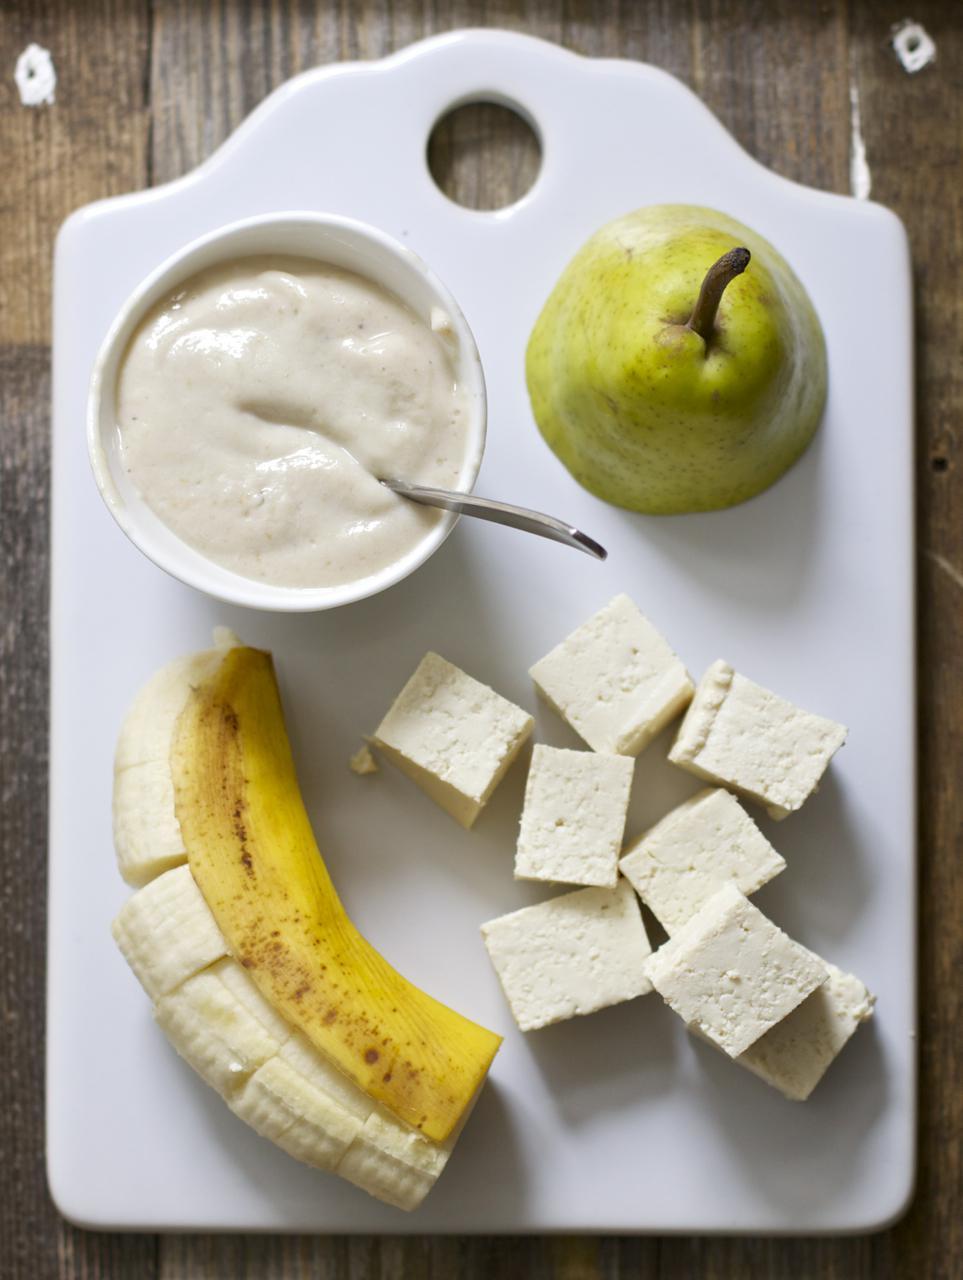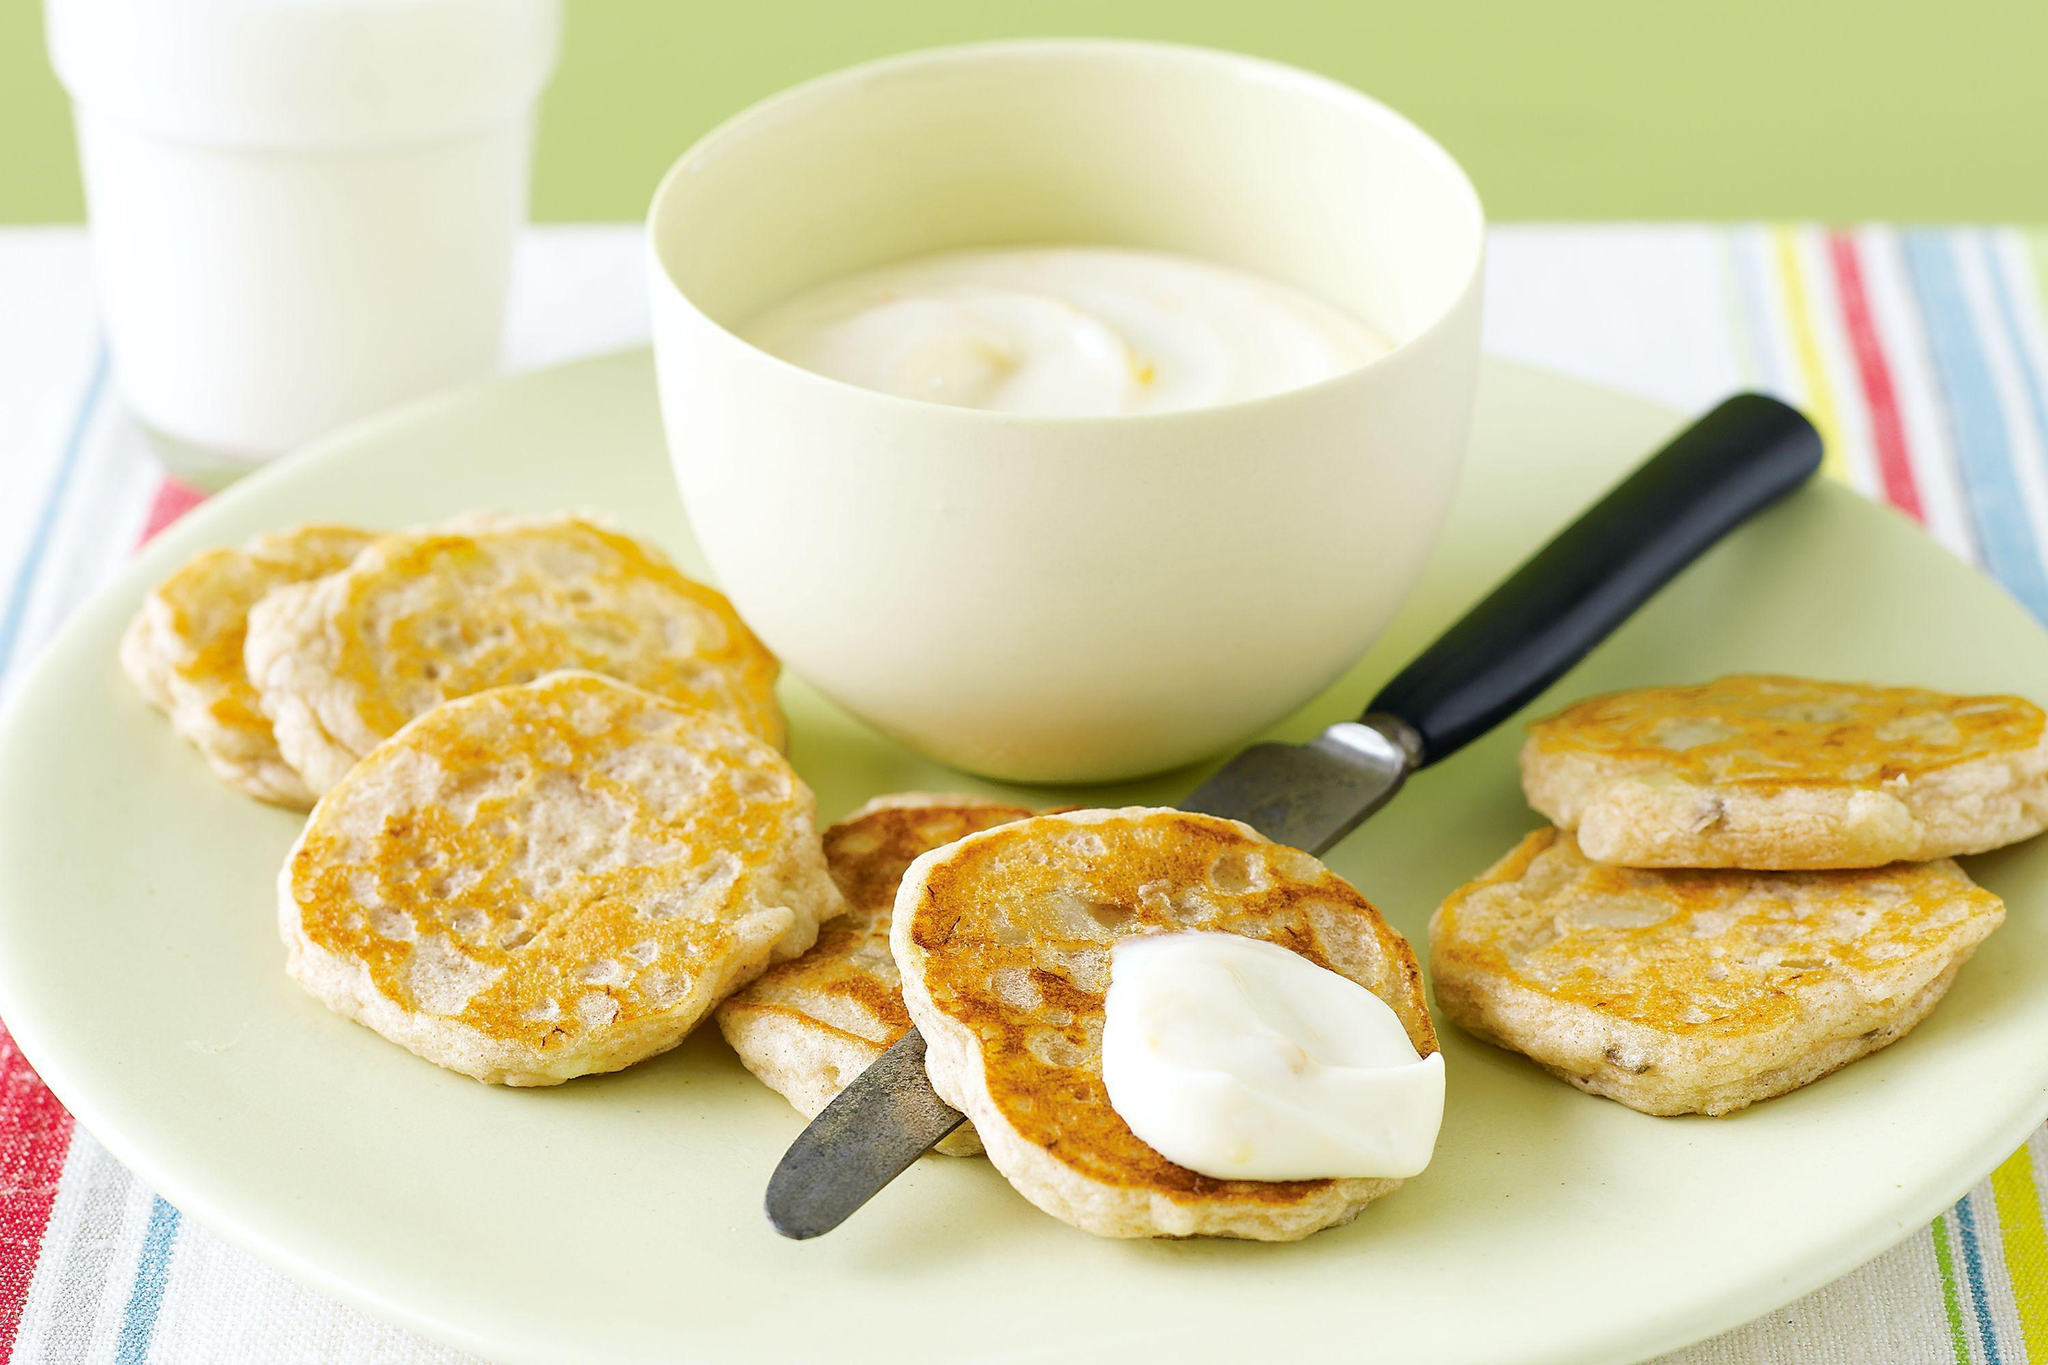The first image is the image on the left, the second image is the image on the right. For the images shown, is this caption "In one image, a glass of breakfast drink with a  straw is in front of whole bananas and at least one pear." true? Answer yes or no. No. The first image is the image on the left, the second image is the image on the right. Considering the images on both sides, is "An image shows intact banana, pear and beverage." valid? Answer yes or no. No. 